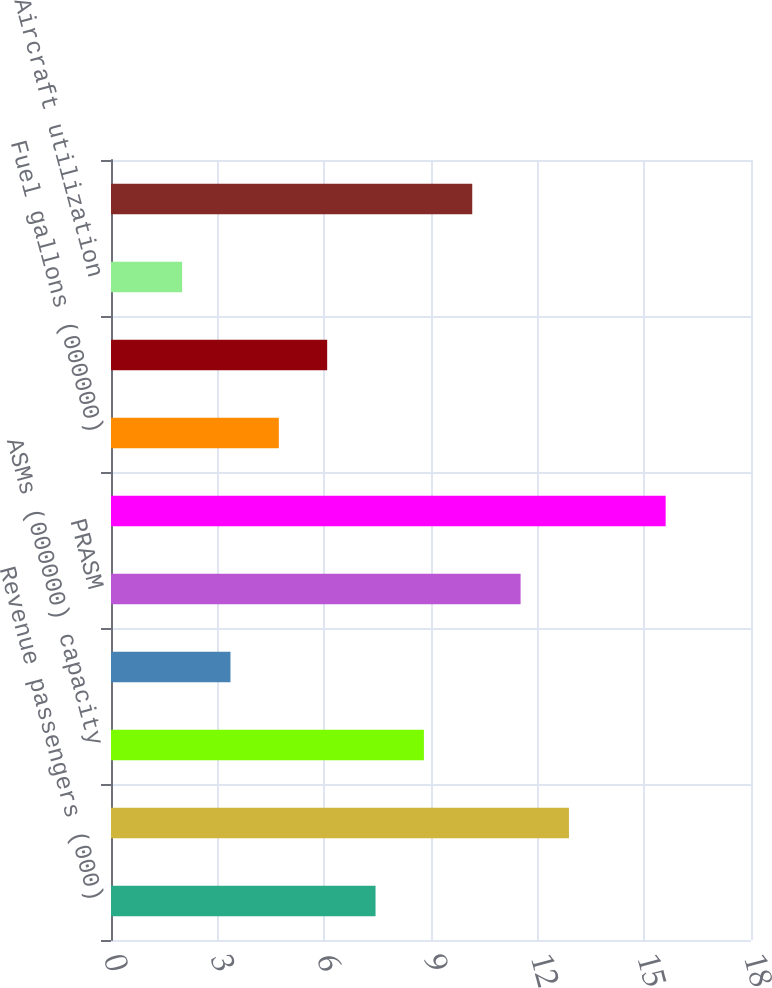Convert chart. <chart><loc_0><loc_0><loc_500><loc_500><bar_chart><fcel>Revenue passengers (000)<fcel>RPMs (000000) traffic<fcel>ASMs (000000) capacity<fcel>Yield<fcel>PRASM<fcel>Economic fuel cost per gallon<fcel>Fuel gallons (000000)<fcel>Average number of full-time<fcel>Aircraft utilization<fcel>Average aircraft stage length<nl><fcel>7.44<fcel>12.88<fcel>8.8<fcel>3.36<fcel>11.52<fcel>15.6<fcel>4.72<fcel>6.08<fcel>2<fcel>10.16<nl></chart> 